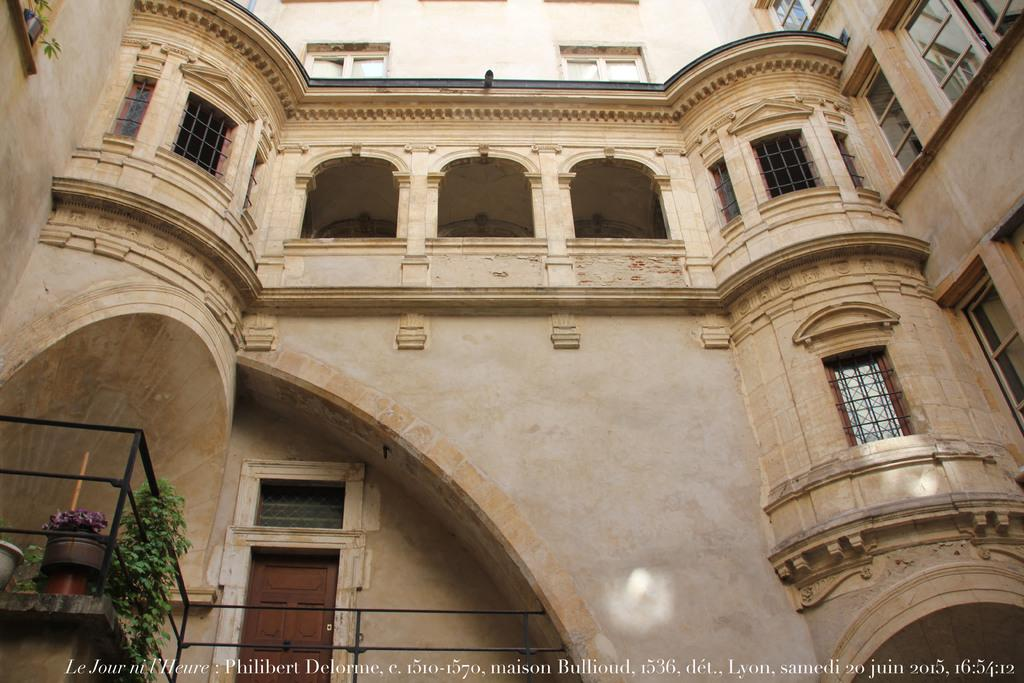What type of structure is visible in the image? There is a building in the image. What features can be seen on the building? The building has windows and doors. What else is present in the image besides the building? There are plants in the image. Can you tell me how many goldfish are swimming in the building's fountain in the image? There is no fountain or goldfish present in the image; it only features a building with windows and doors, along with some plants. 